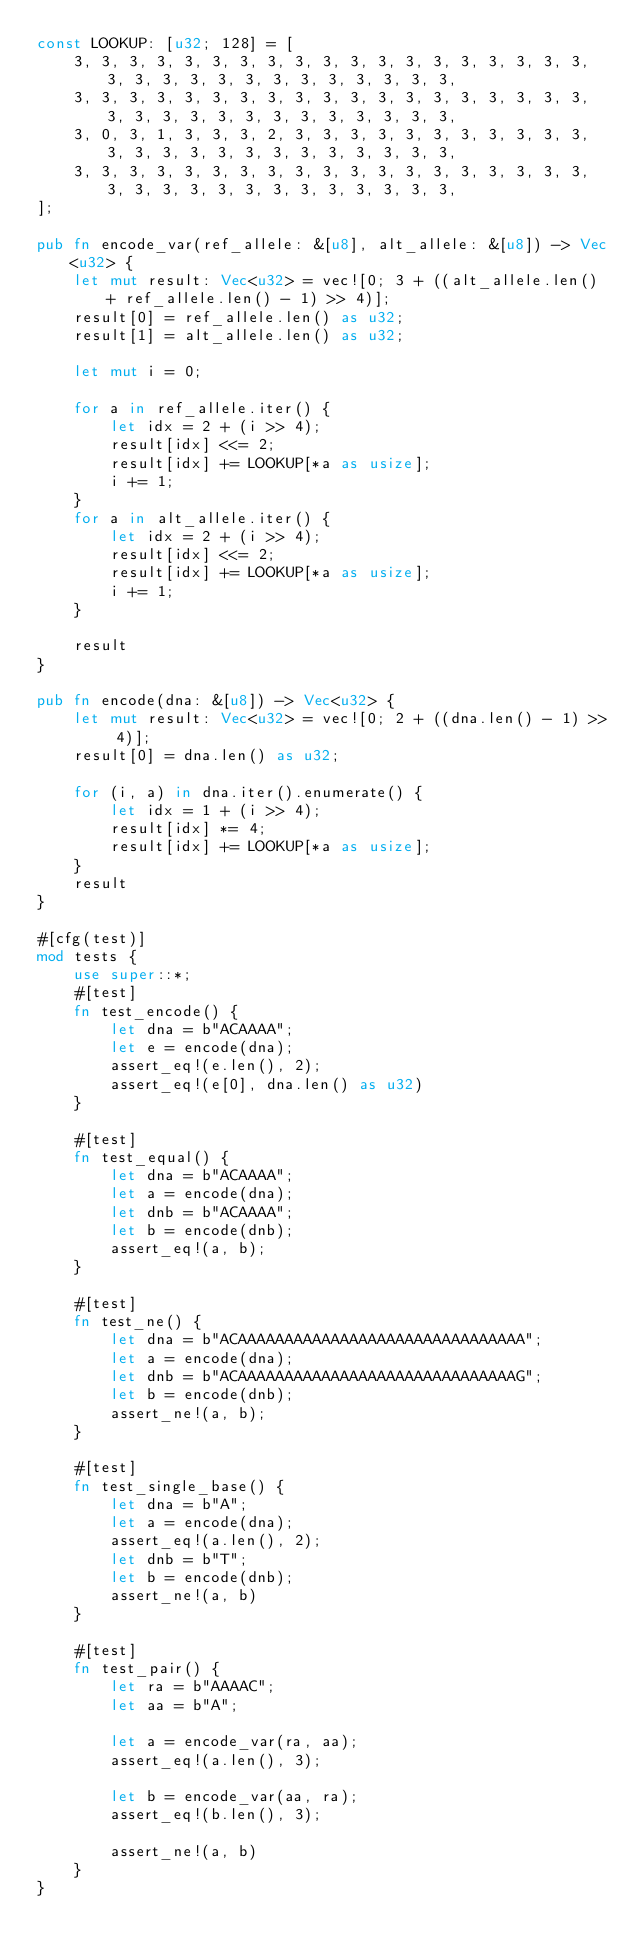Convert code to text. <code><loc_0><loc_0><loc_500><loc_500><_Rust_>const LOOKUP: [u32; 128] = [
    3, 3, 3, 3, 3, 3, 3, 3, 3, 3, 3, 3, 3, 3, 3, 3, 3, 3, 3, 3, 3, 3, 3, 3, 3, 3, 3, 3, 3, 3, 3, 3,
    3, 3, 3, 3, 3, 3, 3, 3, 3, 3, 3, 3, 3, 3, 3, 3, 3, 3, 3, 3, 3, 3, 3, 3, 3, 3, 3, 3, 3, 3, 3, 3,
    3, 0, 3, 1, 3, 3, 3, 2, 3, 3, 3, 3, 3, 3, 3, 3, 3, 3, 3, 3, 3, 3, 3, 3, 3, 3, 3, 3, 3, 3, 3, 3,
    3, 3, 3, 3, 3, 3, 3, 3, 3, 3, 3, 3, 3, 3, 3, 3, 3, 3, 3, 3, 3, 3, 3, 3, 3, 3, 3, 3, 3, 3, 3, 3,
];

pub fn encode_var(ref_allele: &[u8], alt_allele: &[u8]) -> Vec<u32> {
    let mut result: Vec<u32> = vec![0; 3 + ((alt_allele.len() + ref_allele.len() - 1) >> 4)];
    result[0] = ref_allele.len() as u32;
    result[1] = alt_allele.len() as u32;

    let mut i = 0;

    for a in ref_allele.iter() {
        let idx = 2 + (i >> 4);
        result[idx] <<= 2;
        result[idx] += LOOKUP[*a as usize];
        i += 1;
    }
    for a in alt_allele.iter() {
        let idx = 2 + (i >> 4);
        result[idx] <<= 2;
        result[idx] += LOOKUP[*a as usize];
        i += 1;
    }

    result
}

pub fn encode(dna: &[u8]) -> Vec<u32> {
    let mut result: Vec<u32> = vec![0; 2 + ((dna.len() - 1) >> 4)];
    result[0] = dna.len() as u32;

    for (i, a) in dna.iter().enumerate() {
        let idx = 1 + (i >> 4);
        result[idx] *= 4;
        result[idx] += LOOKUP[*a as usize];
    }
    result
}

#[cfg(test)]
mod tests {
    use super::*;
    #[test]
    fn test_encode() {
        let dna = b"ACAAAA";
        let e = encode(dna);
        assert_eq!(e.len(), 2);
        assert_eq!(e[0], dna.len() as u32)
    }

    #[test]
    fn test_equal() {
        let dna = b"ACAAAA";
        let a = encode(dna);
        let dnb = b"ACAAAA";
        let b = encode(dnb);
        assert_eq!(a, b);
    }

    #[test]
    fn test_ne() {
        let dna = b"ACAAAAAAAAAAAAAAAAAAAAAAAAAAAAAAA";
        let a = encode(dna);
        let dnb = b"ACAAAAAAAAAAAAAAAAAAAAAAAAAAAAAAG";
        let b = encode(dnb);
        assert_ne!(a, b);
    }

    #[test]
    fn test_single_base() {
        let dna = b"A";
        let a = encode(dna);
        assert_eq!(a.len(), 2);
        let dnb = b"T";
        let b = encode(dnb);
        assert_ne!(a, b)
    }

    #[test]
    fn test_pair() {
        let ra = b"AAAAC";
        let aa = b"A";

        let a = encode_var(ra, aa);
        assert_eq!(a.len(), 3);

        let b = encode_var(aa, ra);
        assert_eq!(b.len(), 3);

        assert_ne!(a, b)
    }
}
</code> 